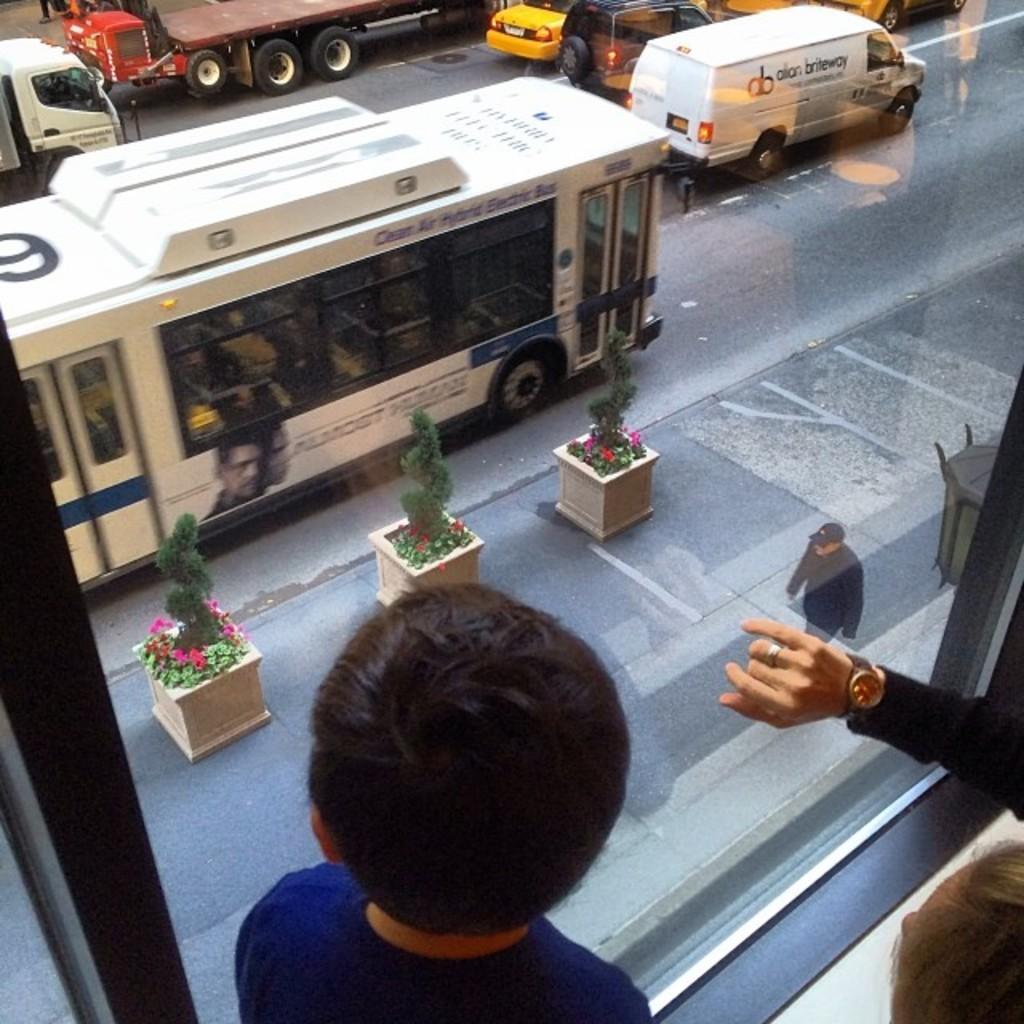Describe this image in one or two sentences. In this image, there are a few people. We can see a glass window. We can see the ground. We can see some plants and flowers. There are a few vehicles. We can see an object. 